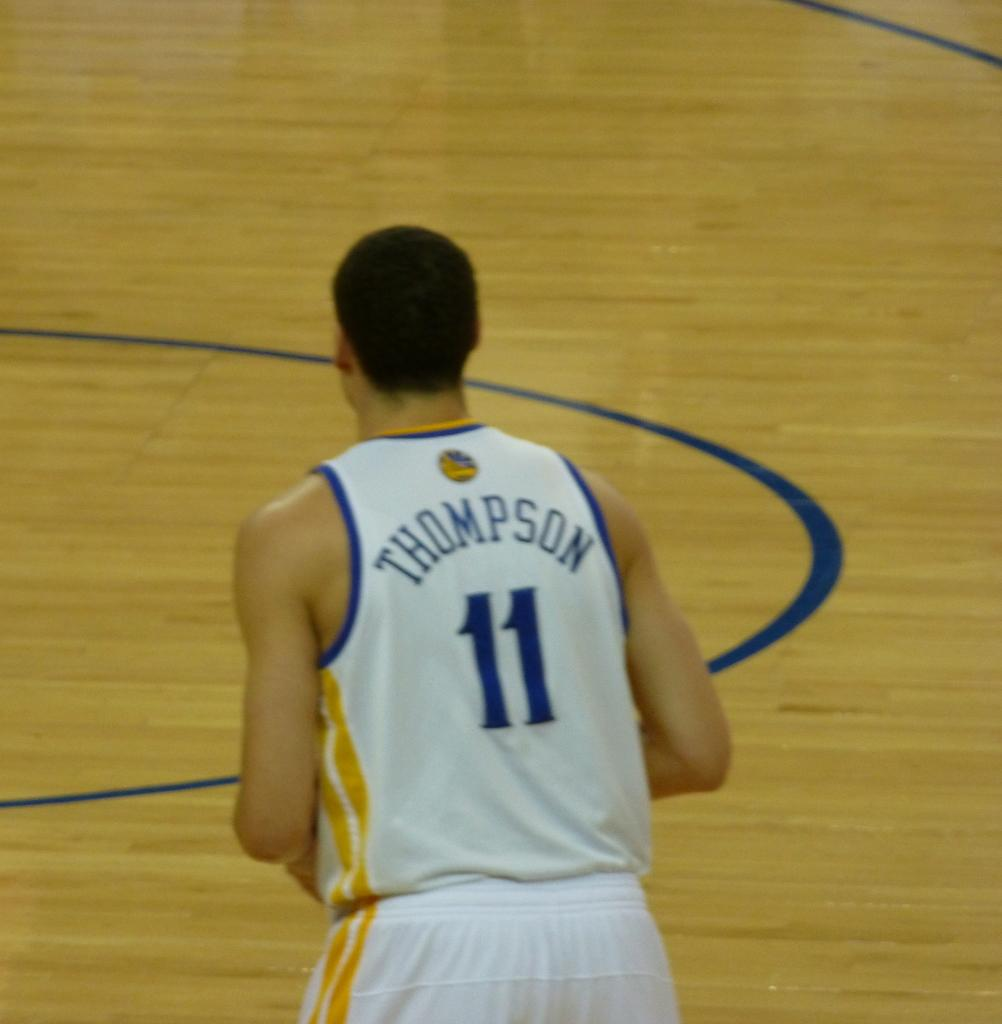Provide a one-sentence caption for the provided image. A basketball player with the last name Thompson hurries down the court. 